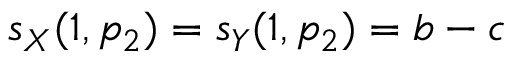Convert formula to latex. <formula><loc_0><loc_0><loc_500><loc_500>s _ { X } ( 1 , p _ { 2 } ) = s _ { Y } ( 1 , p _ { 2 } ) = b - c</formula> 